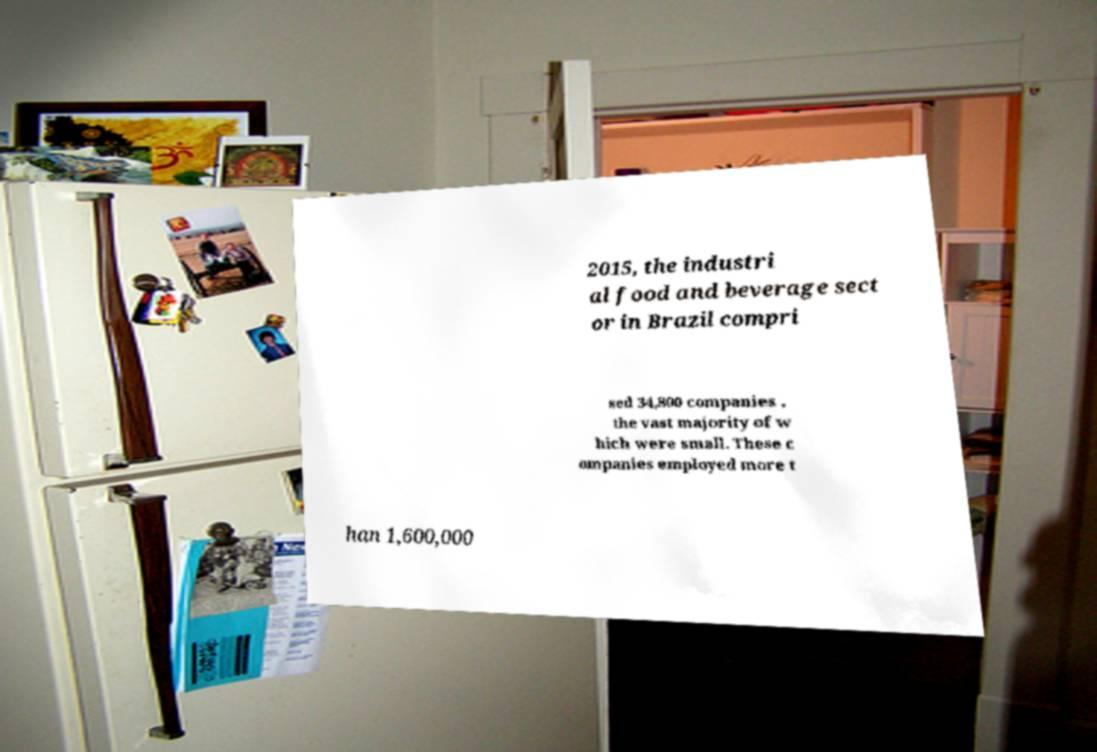There's text embedded in this image that I need extracted. Can you transcribe it verbatim? 2015, the industri al food and beverage sect or in Brazil compri sed 34,800 companies , the vast majority of w hich were small. These c ompanies employed more t han 1,600,000 